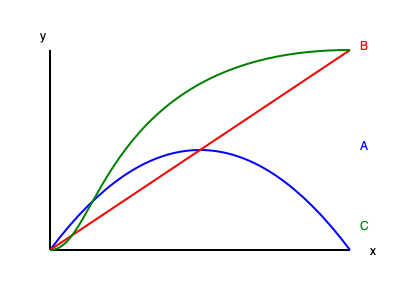Based on your experience with machine learning projects, consider the graph above showing three different activation functions (A, B, and C) commonly used in neural networks. Which of these functions is most likely to mitigate the vanishing gradient problem during training, and why? To answer this question, we need to analyze each activation function and understand their properties:

1. Function A (Blue): This appears to be the sigmoid or logistic function. It has an S-shaped curve that saturates at both extremes.

2. Function B (Red): This is a linear function, represented by a straight line.

3. Function C (Green): This resembles the ReLU (Rectified Linear Unit) function, which is linear for positive inputs and zero for negative inputs.

The vanishing gradient problem occurs when the gradient becomes extremely small during backpropagation, especially in deep neural networks. This can slow down or halt the learning process.

Let's consider each function:

1. Sigmoid (A): Prone to vanishing gradient problem because its derivative is small for large positive or negative inputs, causing gradients to diminish as they propagate backwards.

2. Linear (B): Does not suffer from vanishing gradient, but lacks non-linearity, which limits the network's ability to learn complex patterns.

3. ReLU (C): Addresses the vanishing gradient problem effectively because:
   a) Its derivative is 1 for all positive inputs, allowing gradients to flow without diminishing.
   b) It introduces non-linearity, enabling the network to learn complex patterns.
   c) It's computationally efficient.

Therefore, among these options, the ReLU function (C) is most likely to mitigate the vanishing gradient problem during training.
Answer: ReLU (Function C) 